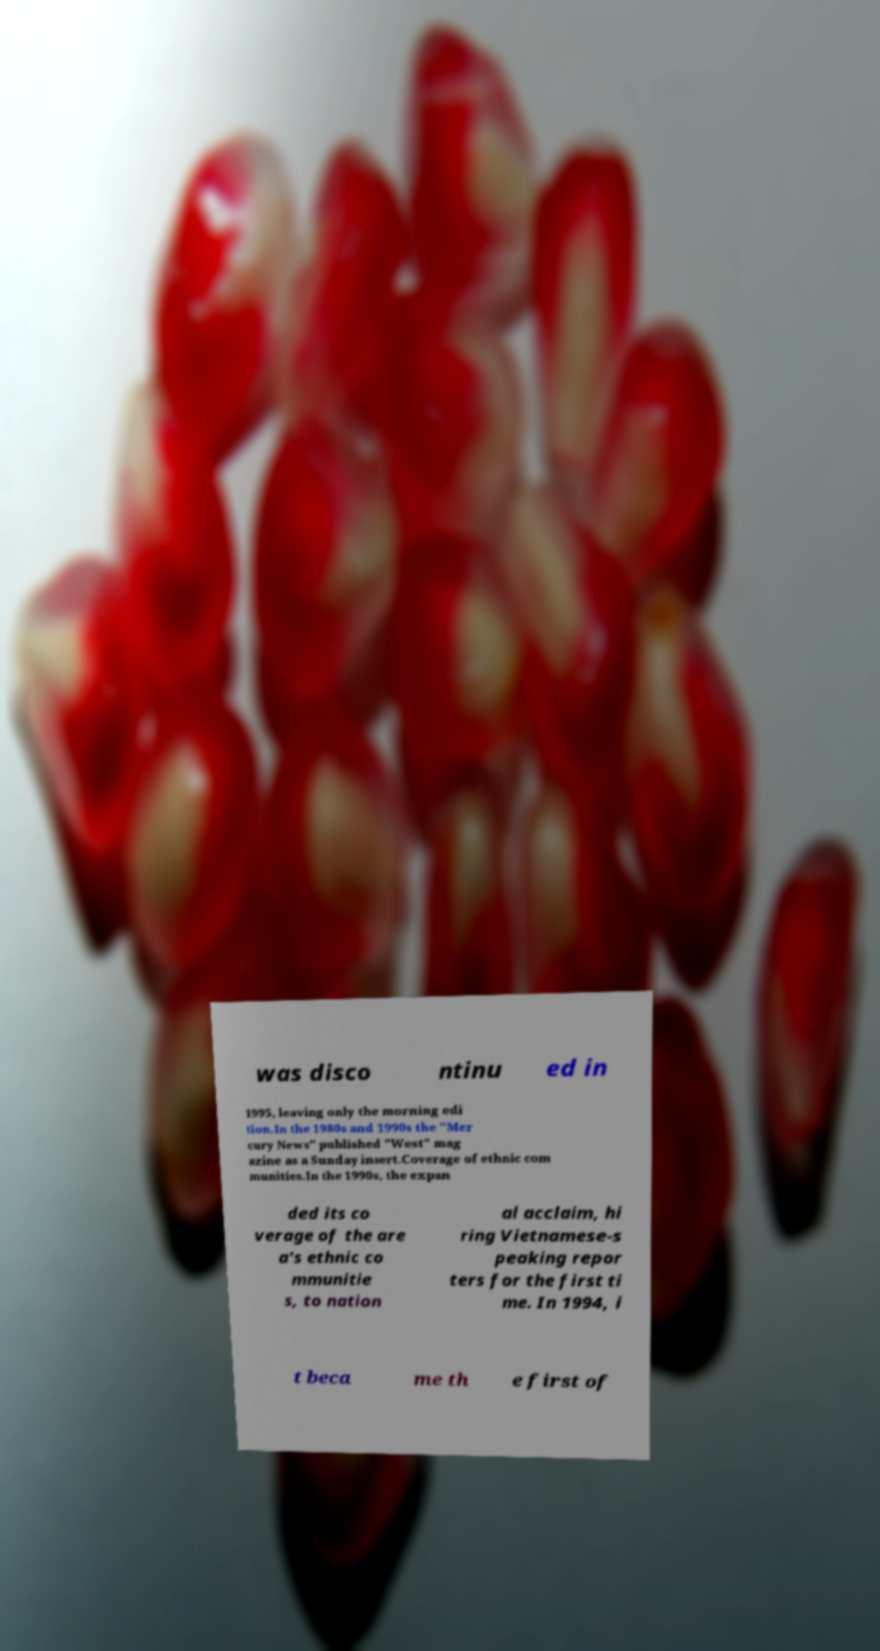Could you extract and type out the text from this image? was disco ntinu ed in 1995, leaving only the morning edi tion.In the 1980s and 1990s the "Mer cury News" published "West" mag azine as a Sunday insert.Coverage of ethnic com munities.In the 1990s, the expan ded its co verage of the are a's ethnic co mmunitie s, to nation al acclaim, hi ring Vietnamese-s peaking repor ters for the first ti me. In 1994, i t beca me th e first of 